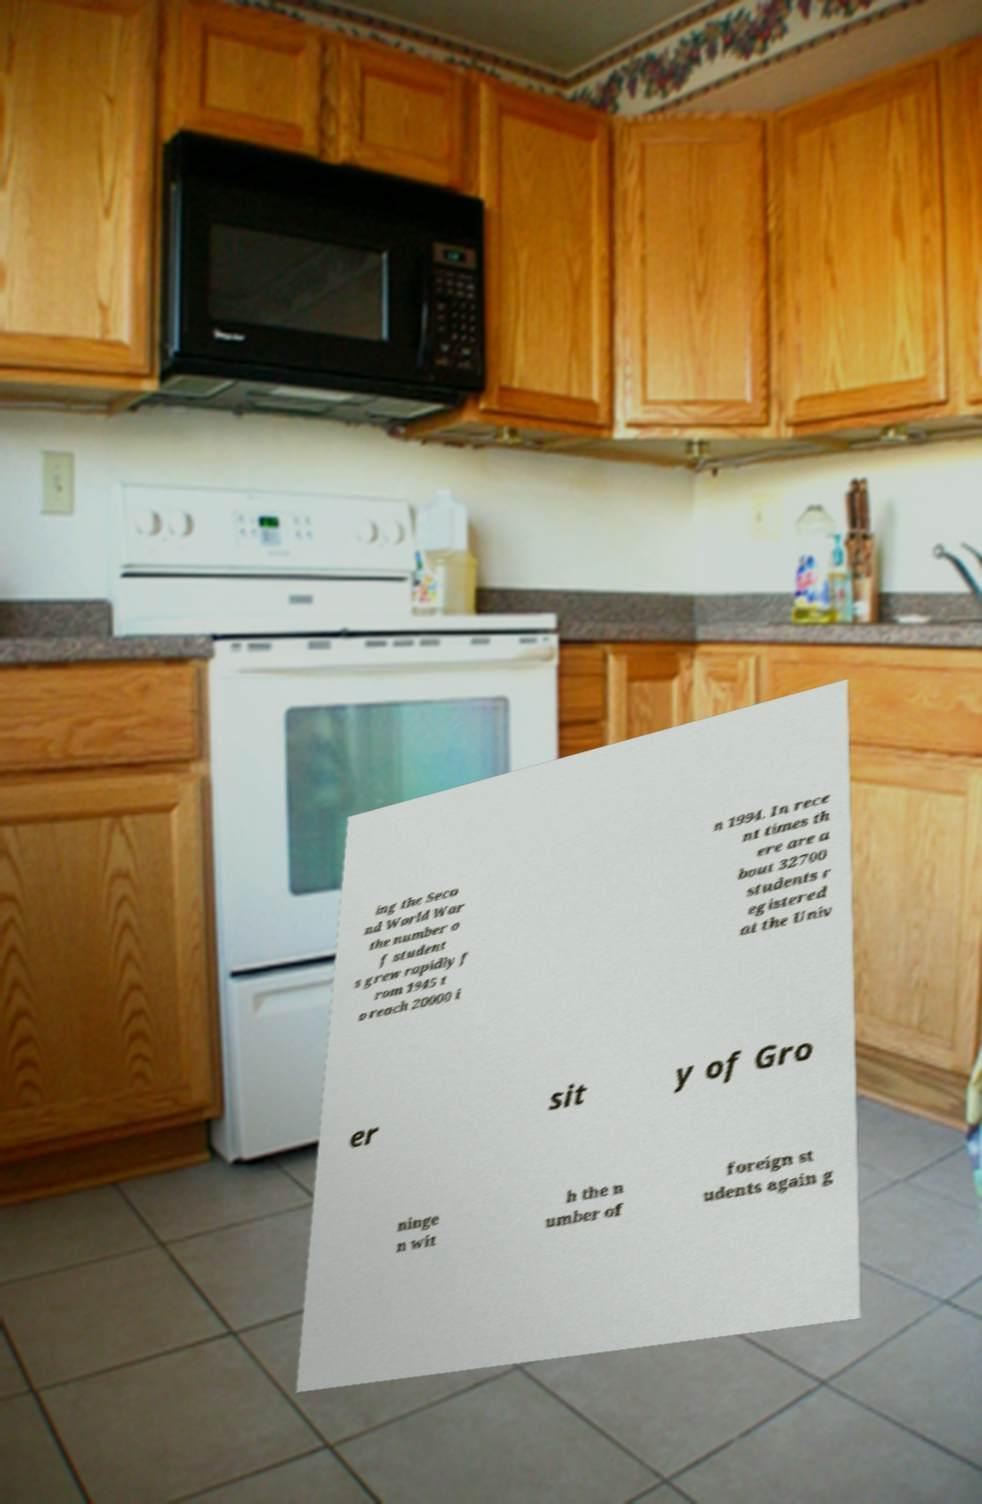Can you read and provide the text displayed in the image?This photo seems to have some interesting text. Can you extract and type it out for me? ing the Seco nd World War the number o f student s grew rapidly f rom 1945 t o reach 20000 i n 1994. In rece nt times th ere are a bout 32700 students r egistered at the Univ er sit y of Gro ninge n wit h the n umber of foreign st udents again g 